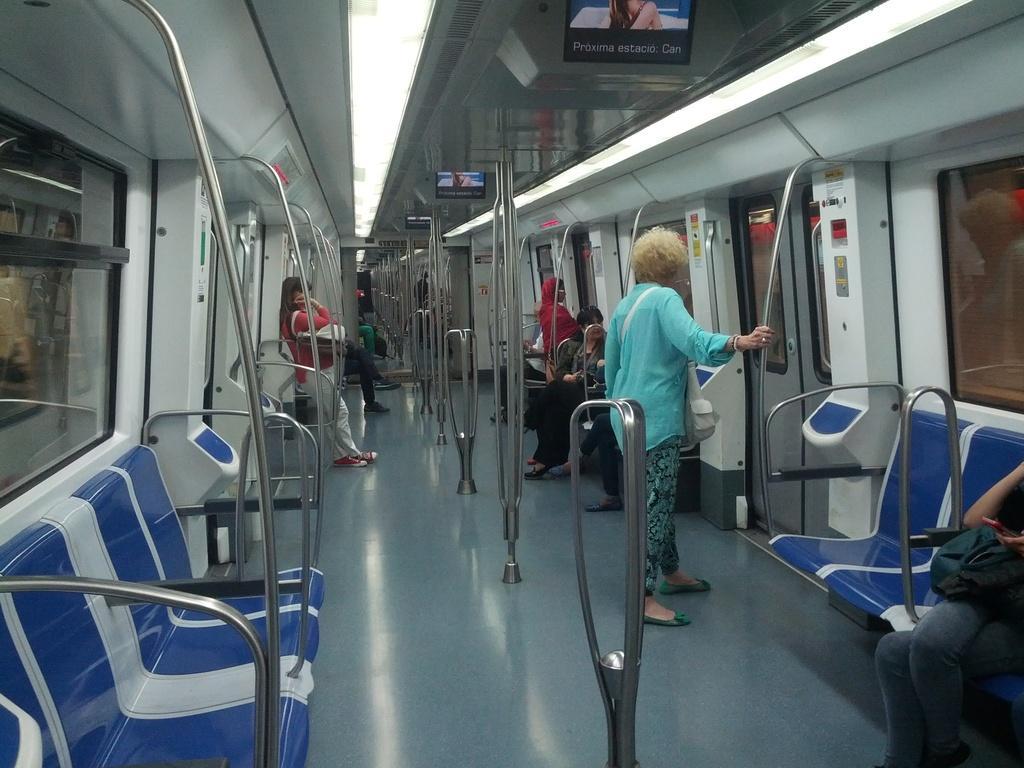Please provide a concise description of this image. In this image, we can see the inner view of a train. There are a few people, poles, screens, posters, seats. We can see the ground. We can also see the doors and the roof with lights. 